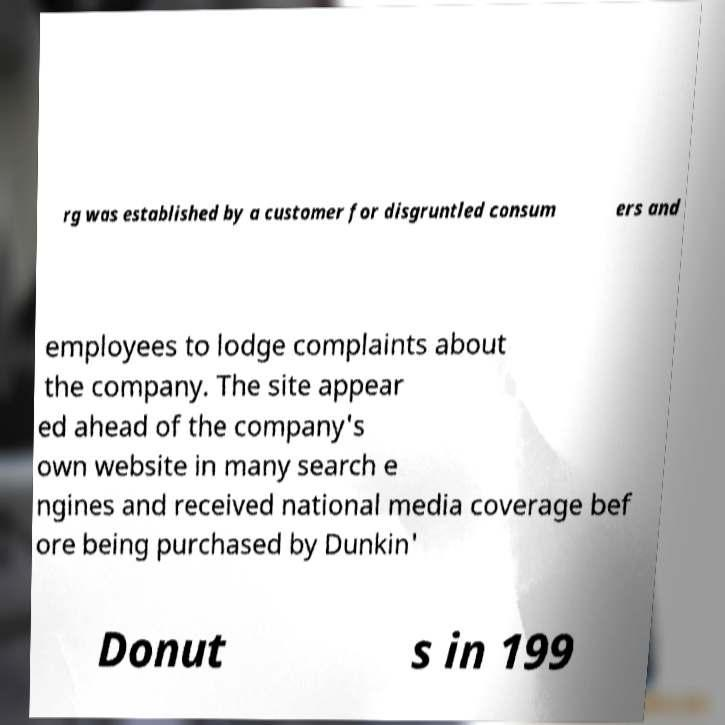Please read and relay the text visible in this image. What does it say? rg was established by a customer for disgruntled consum ers and employees to lodge complaints about the company. The site appear ed ahead of the company's own website in many search e ngines and received national media coverage bef ore being purchased by Dunkin' Donut s in 199 